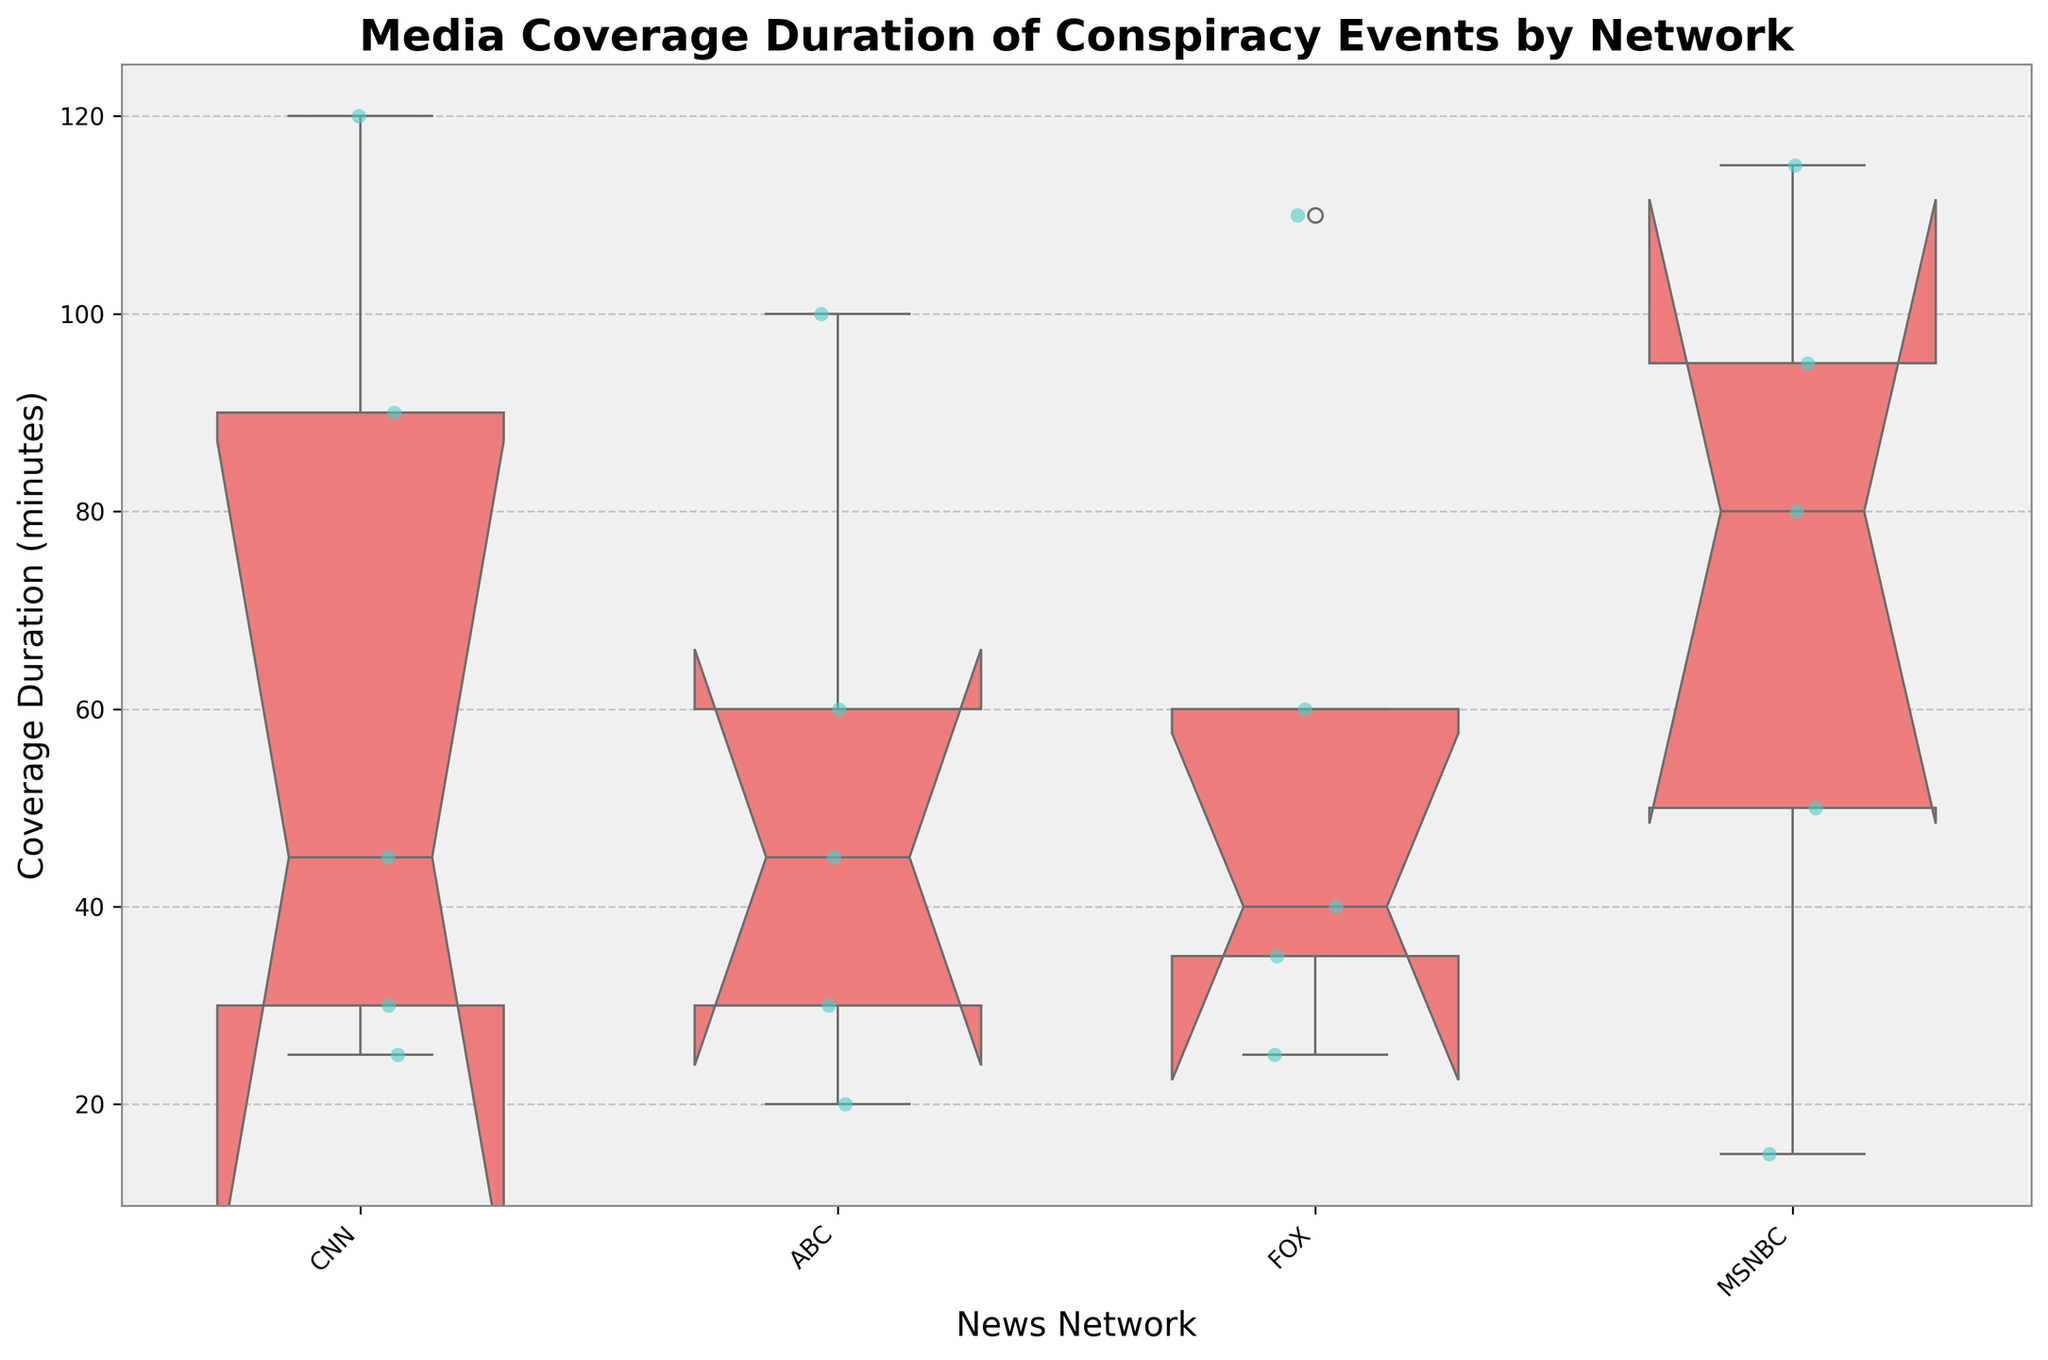what's the title of the plot? To find the title of the plot, look at the top of the chart where titles are usually placed. The title will be in a larger and bolder font compared to the rest of the text.
Answer: Media Coverage Duration of Conspiracy Events by Network how many networks are compared in the plot? The number of networks can be found by counting the distinct categories on the x-axis of the plot, which are labeled with network names.
Answer: 4 which network has the widest range of durations? Identify the range of durations for each network by looking at the size of the boxes and the whiskers in the box plot. The network with the widest spread from minimum to maximum duration has the widest range.
Answer: FOX what is the median duration for CNN? The median duration is represented by the horizontal line inside the box of the box plot for CNN. Observe this line's y-coordinate value.
Answer: 45 minutes which event was discussed the most on MSNBC? By noting the positions of the dots or data points on the y-axis for MSNBC, identify which event has the highest values indicating longer duration.
Answer: Moon Landing what is the interquartile range (IQR) of durations for ABC? The IQR is the range between the first quartile (bottom of the box) and the third quartile (top of the box) of the box plot for ABC. Estimate these values and subtract the first quartile from the third quartile duration.
Answer: 70 minutes - 30 minutes = 40 minutes compare the median duration of CNN and MSNBC. Which is higher? Compare the horizontal lines within the boxes of the CNN and MSNBC box plots. Identify which line is positioned higher on the y-axis.
Answer: CNN is there any network that has an outlier in the data? Outliers are typically represented as individual points outside the whiskers of a box plot. Observe each network to identify if any points are distinctly separate from the range of whiskers.
Answer: Yes, FOX what can you infer from the notches in the box plot? Notches in the box plot indicate a rough significance test for whether medians are different; if the notches of two boxes do not overlap, this suggests that the medians are significantly different. Analyze if there are any non-overlapping notches for a comparison.
Answer: Medians of some networks are significantly different 